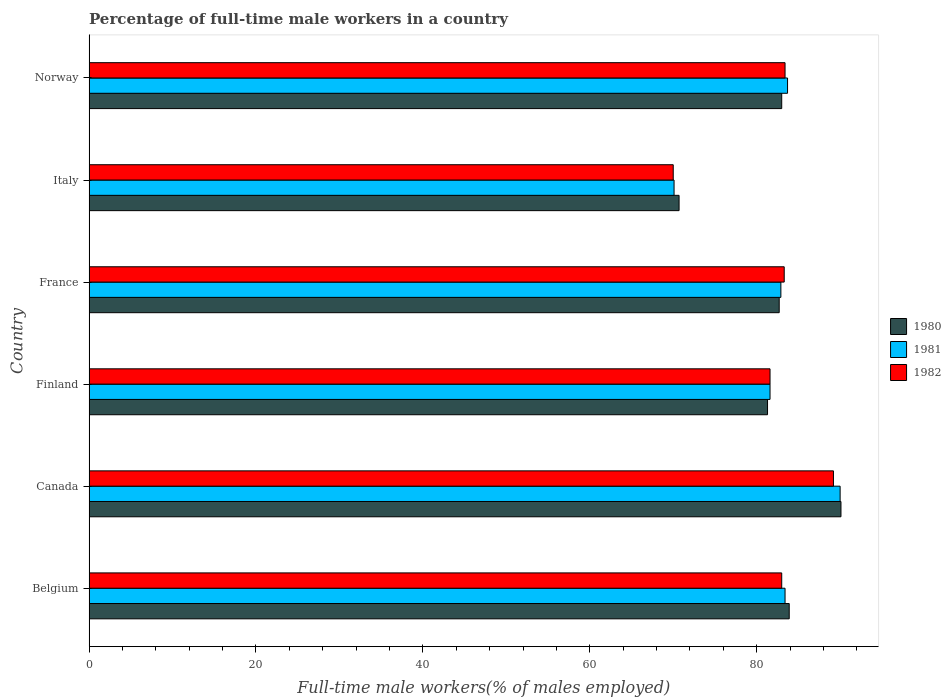Are the number of bars per tick equal to the number of legend labels?
Ensure brevity in your answer.  Yes. Are the number of bars on each tick of the Y-axis equal?
Give a very brief answer. Yes. How many bars are there on the 3rd tick from the top?
Provide a succinct answer. 3. What is the label of the 2nd group of bars from the top?
Offer a very short reply. Italy. What is the percentage of full-time male workers in 1981 in Finland?
Your response must be concise. 81.6. Across all countries, what is the maximum percentage of full-time male workers in 1982?
Offer a terse response. 89.2. In which country was the percentage of full-time male workers in 1982 minimum?
Make the answer very short. Italy. What is the total percentage of full-time male workers in 1980 in the graph?
Your response must be concise. 491.7. What is the difference between the percentage of full-time male workers in 1980 in Belgium and that in Canada?
Your response must be concise. -6.2. What is the difference between the percentage of full-time male workers in 1981 in Canada and the percentage of full-time male workers in 1980 in France?
Give a very brief answer. 7.3. What is the average percentage of full-time male workers in 1980 per country?
Provide a succinct answer. 81.95. What is the difference between the percentage of full-time male workers in 1982 and percentage of full-time male workers in 1981 in Italy?
Make the answer very short. -0.1. What is the ratio of the percentage of full-time male workers in 1981 in Finland to that in Italy?
Your answer should be compact. 1.16. Is the percentage of full-time male workers in 1982 in Belgium less than that in Italy?
Your response must be concise. No. What is the difference between the highest and the second highest percentage of full-time male workers in 1981?
Provide a short and direct response. 6.3. What is the difference between the highest and the lowest percentage of full-time male workers in 1981?
Give a very brief answer. 19.9. In how many countries, is the percentage of full-time male workers in 1980 greater than the average percentage of full-time male workers in 1980 taken over all countries?
Make the answer very short. 4. What does the 1st bar from the top in Norway represents?
Keep it short and to the point. 1982. What does the 3rd bar from the bottom in Belgium represents?
Offer a terse response. 1982. Are all the bars in the graph horizontal?
Your response must be concise. Yes. What is the difference between two consecutive major ticks on the X-axis?
Provide a succinct answer. 20. Are the values on the major ticks of X-axis written in scientific E-notation?
Provide a short and direct response. No. Where does the legend appear in the graph?
Your answer should be very brief. Center right. How many legend labels are there?
Your answer should be compact. 3. What is the title of the graph?
Make the answer very short. Percentage of full-time male workers in a country. Does "1963" appear as one of the legend labels in the graph?
Give a very brief answer. No. What is the label or title of the X-axis?
Keep it short and to the point. Full-time male workers(% of males employed). What is the Full-time male workers(% of males employed) in 1980 in Belgium?
Offer a terse response. 83.9. What is the Full-time male workers(% of males employed) in 1981 in Belgium?
Ensure brevity in your answer.  83.4. What is the Full-time male workers(% of males employed) of 1980 in Canada?
Your answer should be very brief. 90.1. What is the Full-time male workers(% of males employed) of 1982 in Canada?
Provide a succinct answer. 89.2. What is the Full-time male workers(% of males employed) in 1980 in Finland?
Your answer should be compact. 81.3. What is the Full-time male workers(% of males employed) of 1981 in Finland?
Provide a short and direct response. 81.6. What is the Full-time male workers(% of males employed) of 1982 in Finland?
Your answer should be very brief. 81.6. What is the Full-time male workers(% of males employed) in 1980 in France?
Provide a succinct answer. 82.7. What is the Full-time male workers(% of males employed) in 1981 in France?
Your response must be concise. 82.9. What is the Full-time male workers(% of males employed) in 1982 in France?
Your response must be concise. 83.3. What is the Full-time male workers(% of males employed) in 1980 in Italy?
Make the answer very short. 70.7. What is the Full-time male workers(% of males employed) in 1981 in Italy?
Give a very brief answer. 70.1. What is the Full-time male workers(% of males employed) of 1980 in Norway?
Your answer should be very brief. 83. What is the Full-time male workers(% of males employed) in 1981 in Norway?
Your answer should be very brief. 83.7. What is the Full-time male workers(% of males employed) of 1982 in Norway?
Ensure brevity in your answer.  83.4. Across all countries, what is the maximum Full-time male workers(% of males employed) of 1980?
Offer a terse response. 90.1. Across all countries, what is the maximum Full-time male workers(% of males employed) in 1982?
Your answer should be very brief. 89.2. Across all countries, what is the minimum Full-time male workers(% of males employed) of 1980?
Make the answer very short. 70.7. Across all countries, what is the minimum Full-time male workers(% of males employed) of 1981?
Your answer should be compact. 70.1. Across all countries, what is the minimum Full-time male workers(% of males employed) in 1982?
Your answer should be compact. 70. What is the total Full-time male workers(% of males employed) in 1980 in the graph?
Your answer should be very brief. 491.7. What is the total Full-time male workers(% of males employed) in 1981 in the graph?
Offer a terse response. 491.7. What is the total Full-time male workers(% of males employed) of 1982 in the graph?
Provide a short and direct response. 490.5. What is the difference between the Full-time male workers(% of males employed) of 1980 in Belgium and that in Canada?
Your answer should be very brief. -6.2. What is the difference between the Full-time male workers(% of males employed) of 1980 in Belgium and that in Finland?
Your answer should be compact. 2.6. What is the difference between the Full-time male workers(% of males employed) in 1981 in Belgium and that in Finland?
Make the answer very short. 1.8. What is the difference between the Full-time male workers(% of males employed) in 1981 in Belgium and that in France?
Provide a succinct answer. 0.5. What is the difference between the Full-time male workers(% of males employed) in 1981 in Belgium and that in Italy?
Your answer should be compact. 13.3. What is the difference between the Full-time male workers(% of males employed) of 1982 in Belgium and that in Italy?
Offer a very short reply. 13. What is the difference between the Full-time male workers(% of males employed) of 1981 in Belgium and that in Norway?
Give a very brief answer. -0.3. What is the difference between the Full-time male workers(% of males employed) in 1980 in Canada and that in Finland?
Keep it short and to the point. 8.8. What is the difference between the Full-time male workers(% of males employed) of 1981 in Canada and that in Finland?
Offer a very short reply. 8.4. What is the difference between the Full-time male workers(% of males employed) of 1982 in Canada and that in Finland?
Your answer should be compact. 7.6. What is the difference between the Full-time male workers(% of males employed) of 1980 in Canada and that in France?
Provide a succinct answer. 7.4. What is the difference between the Full-time male workers(% of males employed) of 1981 in Canada and that in France?
Your response must be concise. 7.1. What is the difference between the Full-time male workers(% of males employed) of 1980 in Canada and that in Italy?
Offer a terse response. 19.4. What is the difference between the Full-time male workers(% of males employed) in 1982 in Canada and that in Norway?
Your answer should be compact. 5.8. What is the difference between the Full-time male workers(% of males employed) in 1980 in Finland and that in France?
Provide a succinct answer. -1.4. What is the difference between the Full-time male workers(% of males employed) of 1982 in Finland and that in France?
Provide a succinct answer. -1.7. What is the difference between the Full-time male workers(% of males employed) of 1981 in Finland and that in Italy?
Give a very brief answer. 11.5. What is the difference between the Full-time male workers(% of males employed) in 1982 in Finland and that in Italy?
Provide a short and direct response. 11.6. What is the difference between the Full-time male workers(% of males employed) of 1981 in Finland and that in Norway?
Ensure brevity in your answer.  -2.1. What is the difference between the Full-time male workers(% of males employed) of 1982 in Finland and that in Norway?
Your answer should be very brief. -1.8. What is the difference between the Full-time male workers(% of males employed) in 1980 in France and that in Norway?
Give a very brief answer. -0.3. What is the difference between the Full-time male workers(% of males employed) of 1981 in France and that in Norway?
Your answer should be compact. -0.8. What is the difference between the Full-time male workers(% of males employed) in 1980 in Italy and that in Norway?
Your answer should be very brief. -12.3. What is the difference between the Full-time male workers(% of males employed) of 1980 in Belgium and the Full-time male workers(% of males employed) of 1982 in Finland?
Make the answer very short. 2.3. What is the difference between the Full-time male workers(% of males employed) of 1980 in Belgium and the Full-time male workers(% of males employed) of 1981 in France?
Make the answer very short. 1. What is the difference between the Full-time male workers(% of males employed) in 1980 in Belgium and the Full-time male workers(% of males employed) in 1982 in France?
Give a very brief answer. 0.6. What is the difference between the Full-time male workers(% of males employed) in 1980 in Belgium and the Full-time male workers(% of males employed) in 1981 in Italy?
Offer a terse response. 13.8. What is the difference between the Full-time male workers(% of males employed) of 1980 in Belgium and the Full-time male workers(% of males employed) of 1982 in Italy?
Provide a short and direct response. 13.9. What is the difference between the Full-time male workers(% of males employed) in 1980 in Belgium and the Full-time male workers(% of males employed) in 1982 in Norway?
Offer a terse response. 0.5. What is the difference between the Full-time male workers(% of males employed) of 1981 in Canada and the Full-time male workers(% of males employed) of 1982 in Finland?
Make the answer very short. 8.4. What is the difference between the Full-time male workers(% of males employed) in 1980 in Canada and the Full-time male workers(% of males employed) in 1981 in France?
Your answer should be compact. 7.2. What is the difference between the Full-time male workers(% of males employed) of 1981 in Canada and the Full-time male workers(% of males employed) of 1982 in France?
Your answer should be very brief. 6.7. What is the difference between the Full-time male workers(% of males employed) of 1980 in Canada and the Full-time male workers(% of males employed) of 1982 in Italy?
Keep it short and to the point. 20.1. What is the difference between the Full-time male workers(% of males employed) in 1980 in Finland and the Full-time male workers(% of males employed) in 1982 in France?
Provide a short and direct response. -2. What is the difference between the Full-time male workers(% of males employed) in 1980 in Finland and the Full-time male workers(% of males employed) in 1981 in Italy?
Offer a terse response. 11.2. What is the difference between the Full-time male workers(% of males employed) in 1980 in Finland and the Full-time male workers(% of males employed) in 1981 in Norway?
Offer a very short reply. -2.4. What is the difference between the Full-time male workers(% of males employed) of 1980 in Finland and the Full-time male workers(% of males employed) of 1982 in Norway?
Provide a short and direct response. -2.1. What is the difference between the Full-time male workers(% of males employed) of 1981 in Finland and the Full-time male workers(% of males employed) of 1982 in Norway?
Offer a very short reply. -1.8. What is the difference between the Full-time male workers(% of males employed) of 1980 in France and the Full-time male workers(% of males employed) of 1981 in Italy?
Offer a terse response. 12.6. What is the difference between the Full-time male workers(% of males employed) of 1981 in France and the Full-time male workers(% of males employed) of 1982 in Norway?
Give a very brief answer. -0.5. What is the difference between the Full-time male workers(% of males employed) in 1980 in Italy and the Full-time male workers(% of males employed) in 1981 in Norway?
Your answer should be compact. -13. What is the difference between the Full-time male workers(% of males employed) in 1981 in Italy and the Full-time male workers(% of males employed) in 1982 in Norway?
Give a very brief answer. -13.3. What is the average Full-time male workers(% of males employed) in 1980 per country?
Provide a succinct answer. 81.95. What is the average Full-time male workers(% of males employed) in 1981 per country?
Your answer should be very brief. 81.95. What is the average Full-time male workers(% of males employed) of 1982 per country?
Your answer should be very brief. 81.75. What is the difference between the Full-time male workers(% of males employed) of 1981 and Full-time male workers(% of males employed) of 1982 in Belgium?
Ensure brevity in your answer.  0.4. What is the difference between the Full-time male workers(% of males employed) of 1980 and Full-time male workers(% of males employed) of 1982 in Canada?
Provide a succinct answer. 0.9. What is the difference between the Full-time male workers(% of males employed) in 1981 and Full-time male workers(% of males employed) in 1982 in Finland?
Keep it short and to the point. 0. What is the difference between the Full-time male workers(% of males employed) of 1980 and Full-time male workers(% of males employed) of 1981 in France?
Your answer should be very brief. -0.2. What is the difference between the Full-time male workers(% of males employed) of 1980 and Full-time male workers(% of males employed) of 1982 in France?
Provide a short and direct response. -0.6. What is the difference between the Full-time male workers(% of males employed) of 1981 and Full-time male workers(% of males employed) of 1982 in France?
Provide a short and direct response. -0.4. What is the difference between the Full-time male workers(% of males employed) of 1980 and Full-time male workers(% of males employed) of 1982 in Italy?
Make the answer very short. 0.7. What is the difference between the Full-time male workers(% of males employed) of 1980 and Full-time male workers(% of males employed) of 1981 in Norway?
Your answer should be very brief. -0.7. What is the difference between the Full-time male workers(% of males employed) of 1981 and Full-time male workers(% of males employed) of 1982 in Norway?
Ensure brevity in your answer.  0.3. What is the ratio of the Full-time male workers(% of males employed) in 1980 in Belgium to that in Canada?
Give a very brief answer. 0.93. What is the ratio of the Full-time male workers(% of males employed) in 1981 in Belgium to that in Canada?
Make the answer very short. 0.93. What is the ratio of the Full-time male workers(% of males employed) of 1982 in Belgium to that in Canada?
Your answer should be compact. 0.93. What is the ratio of the Full-time male workers(% of males employed) in 1980 in Belgium to that in Finland?
Offer a very short reply. 1.03. What is the ratio of the Full-time male workers(% of males employed) in 1981 in Belgium to that in Finland?
Give a very brief answer. 1.02. What is the ratio of the Full-time male workers(% of males employed) in 1982 in Belgium to that in Finland?
Your response must be concise. 1.02. What is the ratio of the Full-time male workers(% of males employed) in 1980 in Belgium to that in France?
Ensure brevity in your answer.  1.01. What is the ratio of the Full-time male workers(% of males employed) in 1981 in Belgium to that in France?
Make the answer very short. 1.01. What is the ratio of the Full-time male workers(% of males employed) in 1980 in Belgium to that in Italy?
Provide a short and direct response. 1.19. What is the ratio of the Full-time male workers(% of males employed) in 1981 in Belgium to that in Italy?
Ensure brevity in your answer.  1.19. What is the ratio of the Full-time male workers(% of males employed) of 1982 in Belgium to that in Italy?
Offer a very short reply. 1.19. What is the ratio of the Full-time male workers(% of males employed) in 1980 in Belgium to that in Norway?
Give a very brief answer. 1.01. What is the ratio of the Full-time male workers(% of males employed) in 1982 in Belgium to that in Norway?
Make the answer very short. 1. What is the ratio of the Full-time male workers(% of males employed) in 1980 in Canada to that in Finland?
Offer a terse response. 1.11. What is the ratio of the Full-time male workers(% of males employed) of 1981 in Canada to that in Finland?
Provide a succinct answer. 1.1. What is the ratio of the Full-time male workers(% of males employed) in 1982 in Canada to that in Finland?
Your answer should be very brief. 1.09. What is the ratio of the Full-time male workers(% of males employed) in 1980 in Canada to that in France?
Provide a succinct answer. 1.09. What is the ratio of the Full-time male workers(% of males employed) in 1981 in Canada to that in France?
Your answer should be very brief. 1.09. What is the ratio of the Full-time male workers(% of males employed) of 1982 in Canada to that in France?
Your answer should be very brief. 1.07. What is the ratio of the Full-time male workers(% of males employed) in 1980 in Canada to that in Italy?
Your answer should be very brief. 1.27. What is the ratio of the Full-time male workers(% of males employed) of 1981 in Canada to that in Italy?
Ensure brevity in your answer.  1.28. What is the ratio of the Full-time male workers(% of males employed) in 1982 in Canada to that in Italy?
Your answer should be very brief. 1.27. What is the ratio of the Full-time male workers(% of males employed) of 1980 in Canada to that in Norway?
Your response must be concise. 1.09. What is the ratio of the Full-time male workers(% of males employed) in 1981 in Canada to that in Norway?
Offer a terse response. 1.08. What is the ratio of the Full-time male workers(% of males employed) of 1982 in Canada to that in Norway?
Provide a succinct answer. 1.07. What is the ratio of the Full-time male workers(% of males employed) of 1980 in Finland to that in France?
Make the answer very short. 0.98. What is the ratio of the Full-time male workers(% of males employed) in 1981 in Finland to that in France?
Your response must be concise. 0.98. What is the ratio of the Full-time male workers(% of males employed) of 1982 in Finland to that in France?
Provide a succinct answer. 0.98. What is the ratio of the Full-time male workers(% of males employed) in 1980 in Finland to that in Italy?
Keep it short and to the point. 1.15. What is the ratio of the Full-time male workers(% of males employed) of 1981 in Finland to that in Italy?
Provide a succinct answer. 1.16. What is the ratio of the Full-time male workers(% of males employed) in 1982 in Finland to that in Italy?
Your answer should be compact. 1.17. What is the ratio of the Full-time male workers(% of males employed) in 1980 in Finland to that in Norway?
Your answer should be very brief. 0.98. What is the ratio of the Full-time male workers(% of males employed) of 1981 in Finland to that in Norway?
Your answer should be very brief. 0.97. What is the ratio of the Full-time male workers(% of males employed) in 1982 in Finland to that in Norway?
Give a very brief answer. 0.98. What is the ratio of the Full-time male workers(% of males employed) in 1980 in France to that in Italy?
Provide a short and direct response. 1.17. What is the ratio of the Full-time male workers(% of males employed) in 1981 in France to that in Italy?
Provide a succinct answer. 1.18. What is the ratio of the Full-time male workers(% of males employed) of 1982 in France to that in Italy?
Offer a very short reply. 1.19. What is the ratio of the Full-time male workers(% of males employed) of 1980 in France to that in Norway?
Ensure brevity in your answer.  1. What is the ratio of the Full-time male workers(% of males employed) in 1980 in Italy to that in Norway?
Offer a terse response. 0.85. What is the ratio of the Full-time male workers(% of males employed) of 1981 in Italy to that in Norway?
Provide a short and direct response. 0.84. What is the ratio of the Full-time male workers(% of males employed) of 1982 in Italy to that in Norway?
Give a very brief answer. 0.84. What is the difference between the highest and the lowest Full-time male workers(% of males employed) of 1982?
Offer a terse response. 19.2. 